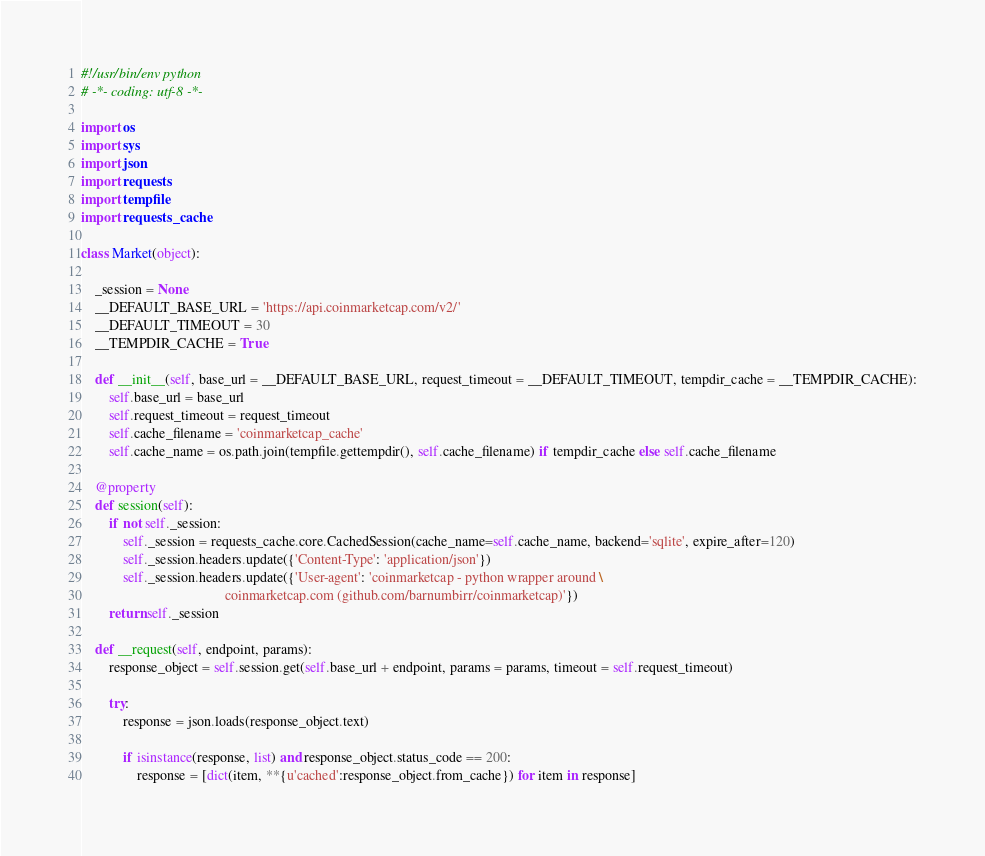Convert code to text. <code><loc_0><loc_0><loc_500><loc_500><_Python_>#!/usr/bin/env python
# -*- coding: utf-8 -*-

import os
import sys
import json
import requests
import tempfile
import requests_cache

class Market(object):

	_session = None
	__DEFAULT_BASE_URL = 'https://api.coinmarketcap.com/v2/'
	__DEFAULT_TIMEOUT = 30
	__TEMPDIR_CACHE = True

	def __init__(self, base_url = __DEFAULT_BASE_URL, request_timeout = __DEFAULT_TIMEOUT, tempdir_cache = __TEMPDIR_CACHE):
		self.base_url = base_url
		self.request_timeout = request_timeout
		self.cache_filename = 'coinmarketcap_cache'
		self.cache_name = os.path.join(tempfile.gettempdir(), self.cache_filename) if tempdir_cache else self.cache_filename

	@property
	def session(self):
		if not self._session:
			self._session = requests_cache.core.CachedSession(cache_name=self.cache_name, backend='sqlite', expire_after=120)
			self._session.headers.update({'Content-Type': 'application/json'})
			self._session.headers.update({'User-agent': 'coinmarketcap - python wrapper around \
			                             coinmarketcap.com (github.com/barnumbirr/coinmarketcap)'})
		return self._session

	def __request(self, endpoint, params):
		response_object = self.session.get(self.base_url + endpoint, params = params, timeout = self.request_timeout)

		try:
			response = json.loads(response_object.text)

			if isinstance(response, list) and response_object.status_code == 200:
				response = [dict(item, **{u'cached':response_object.from_cache}) for item in response]</code> 